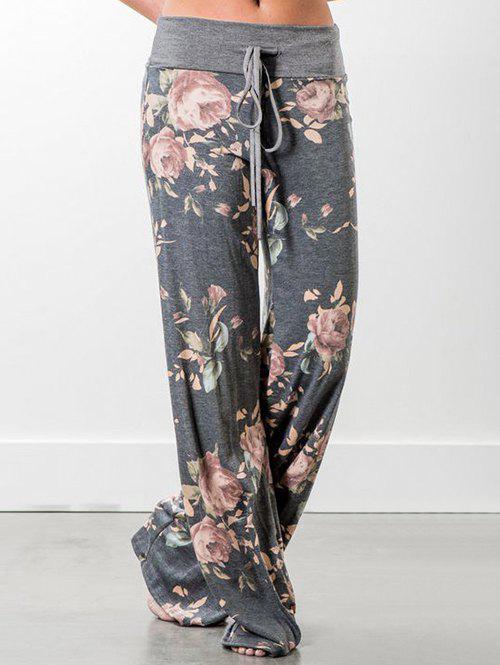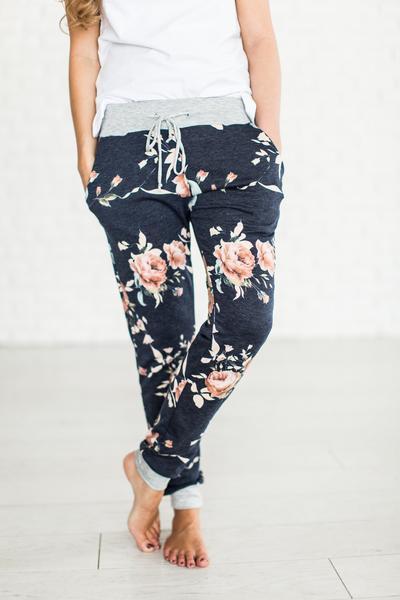The first image is the image on the left, the second image is the image on the right. Examine the images to the left and right. Is the description "A person is wearing the clothing on the right." accurate? Answer yes or no. Yes. 